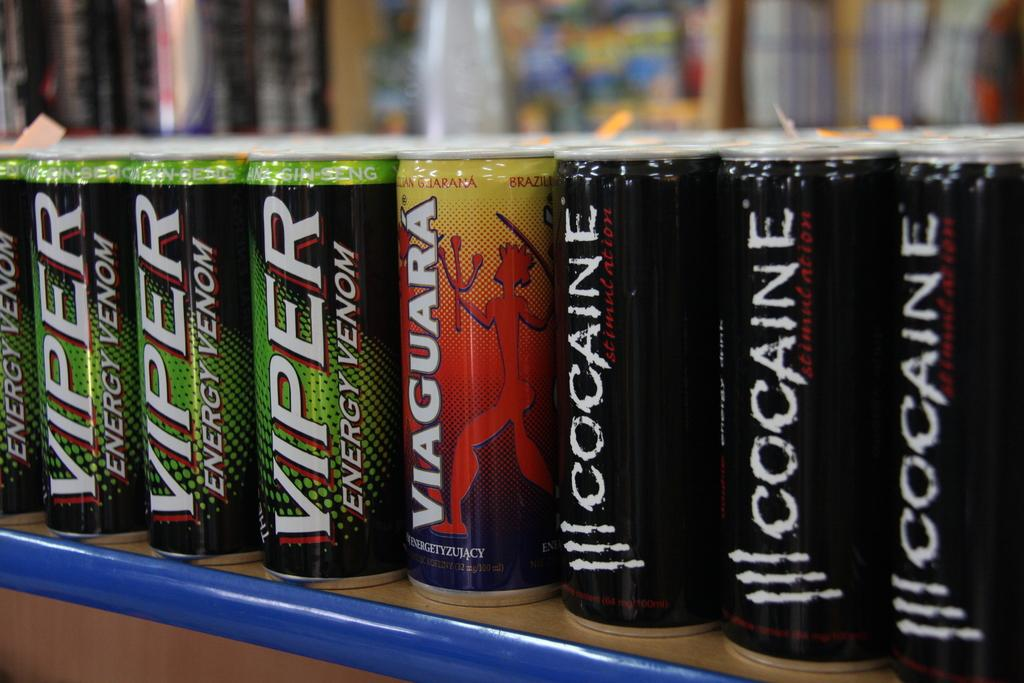<image>
Describe the image concisely. a viper can among many other cans together 